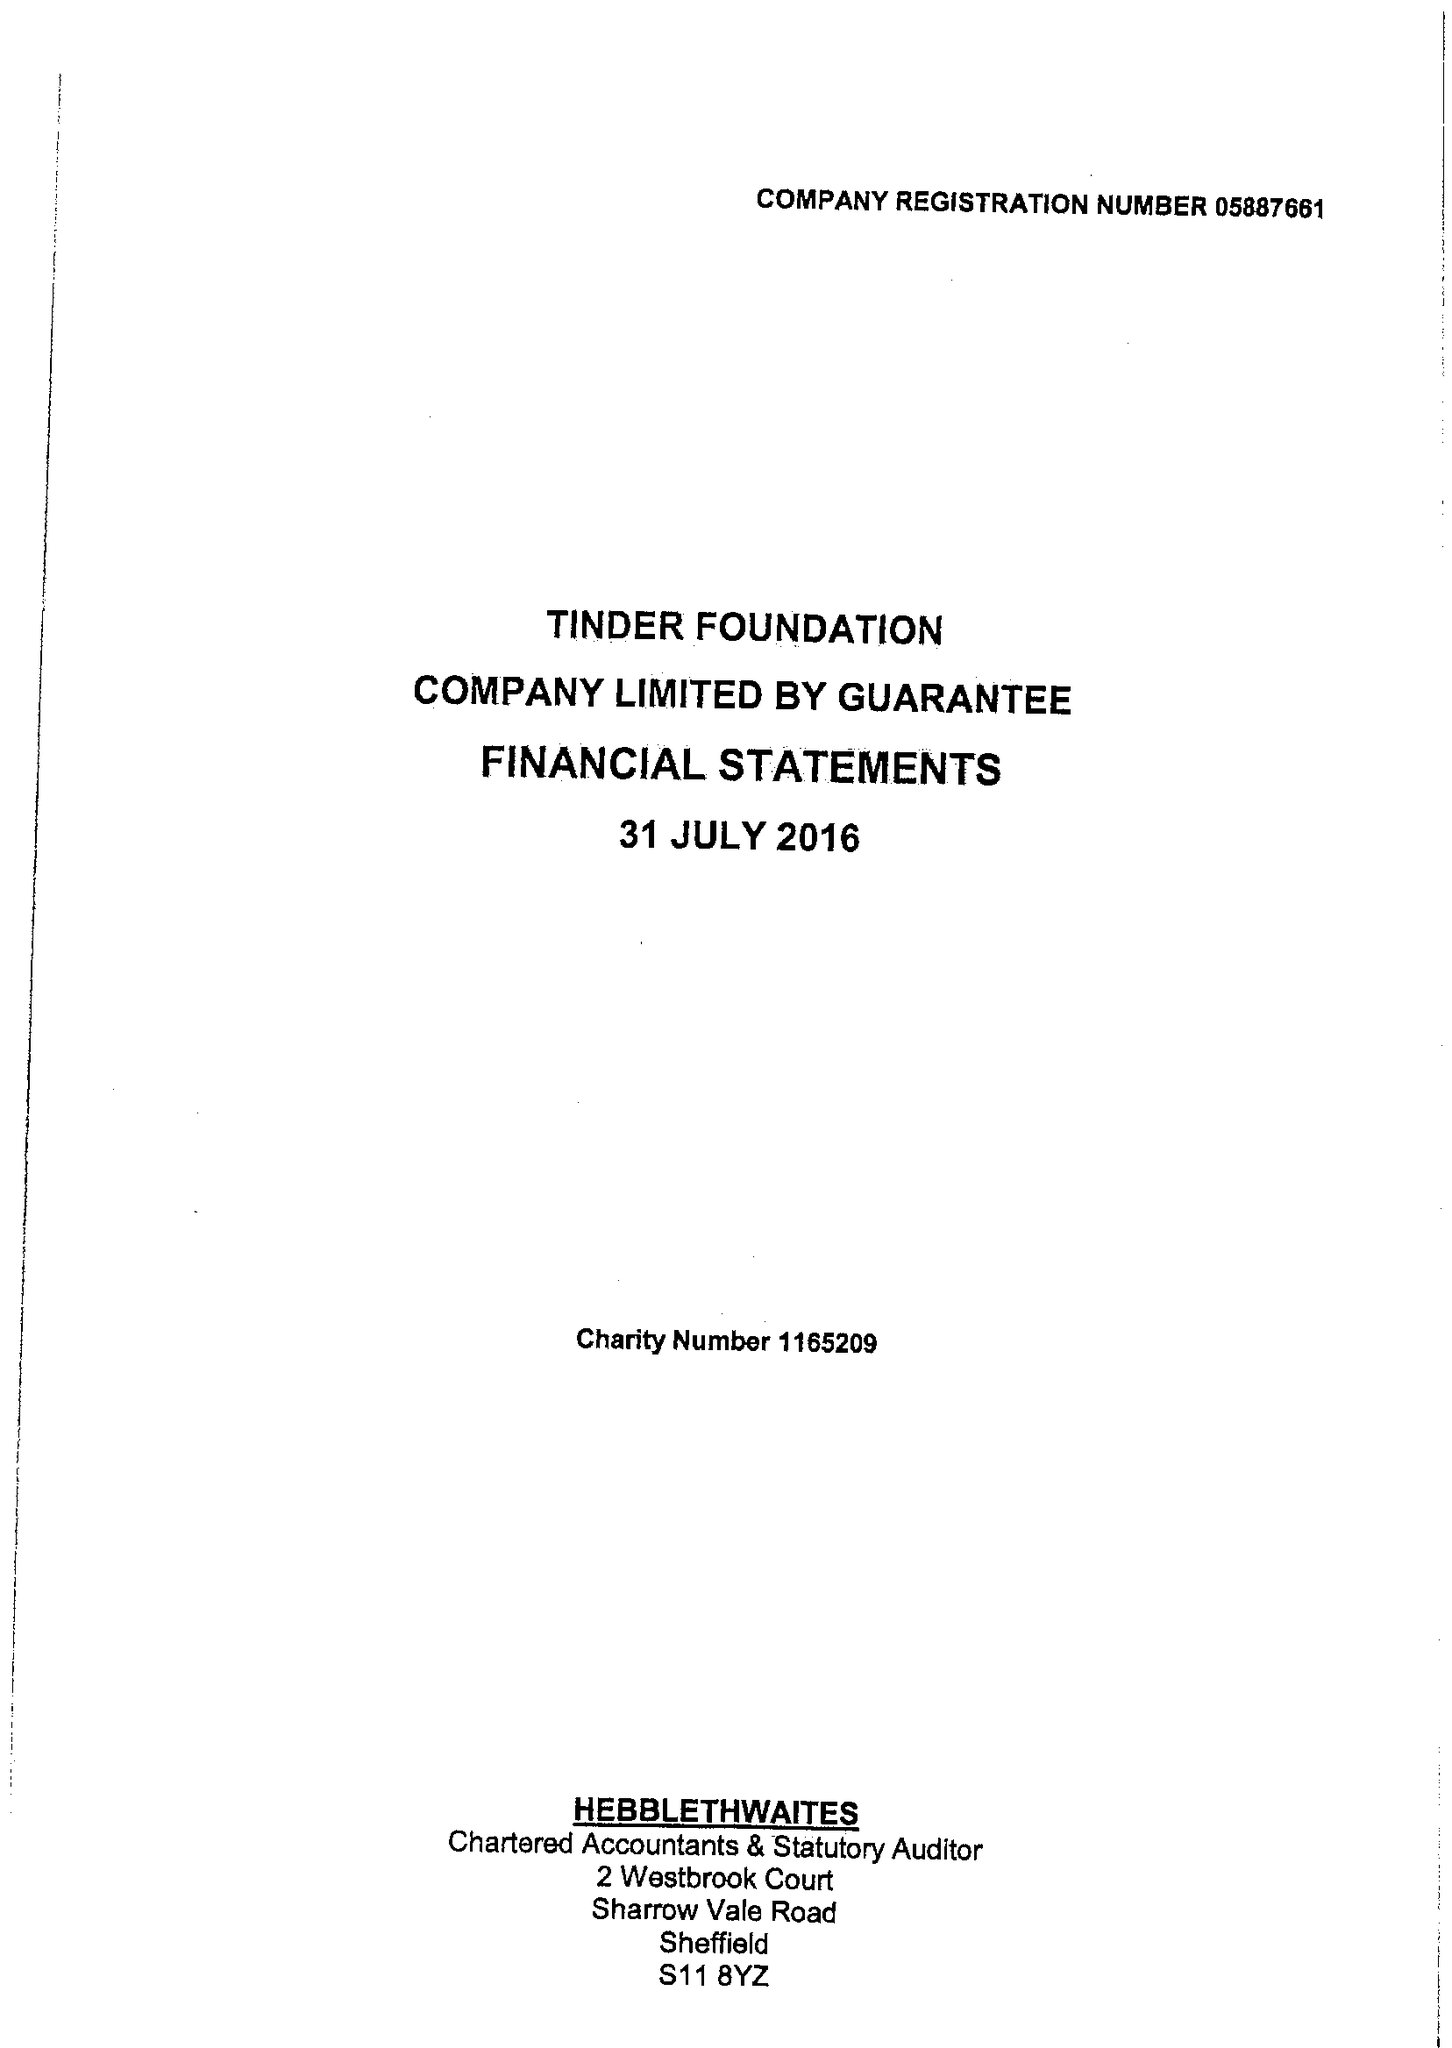What is the value for the income_annually_in_british_pounds?
Answer the question using a single word or phrase. 6261537.00 